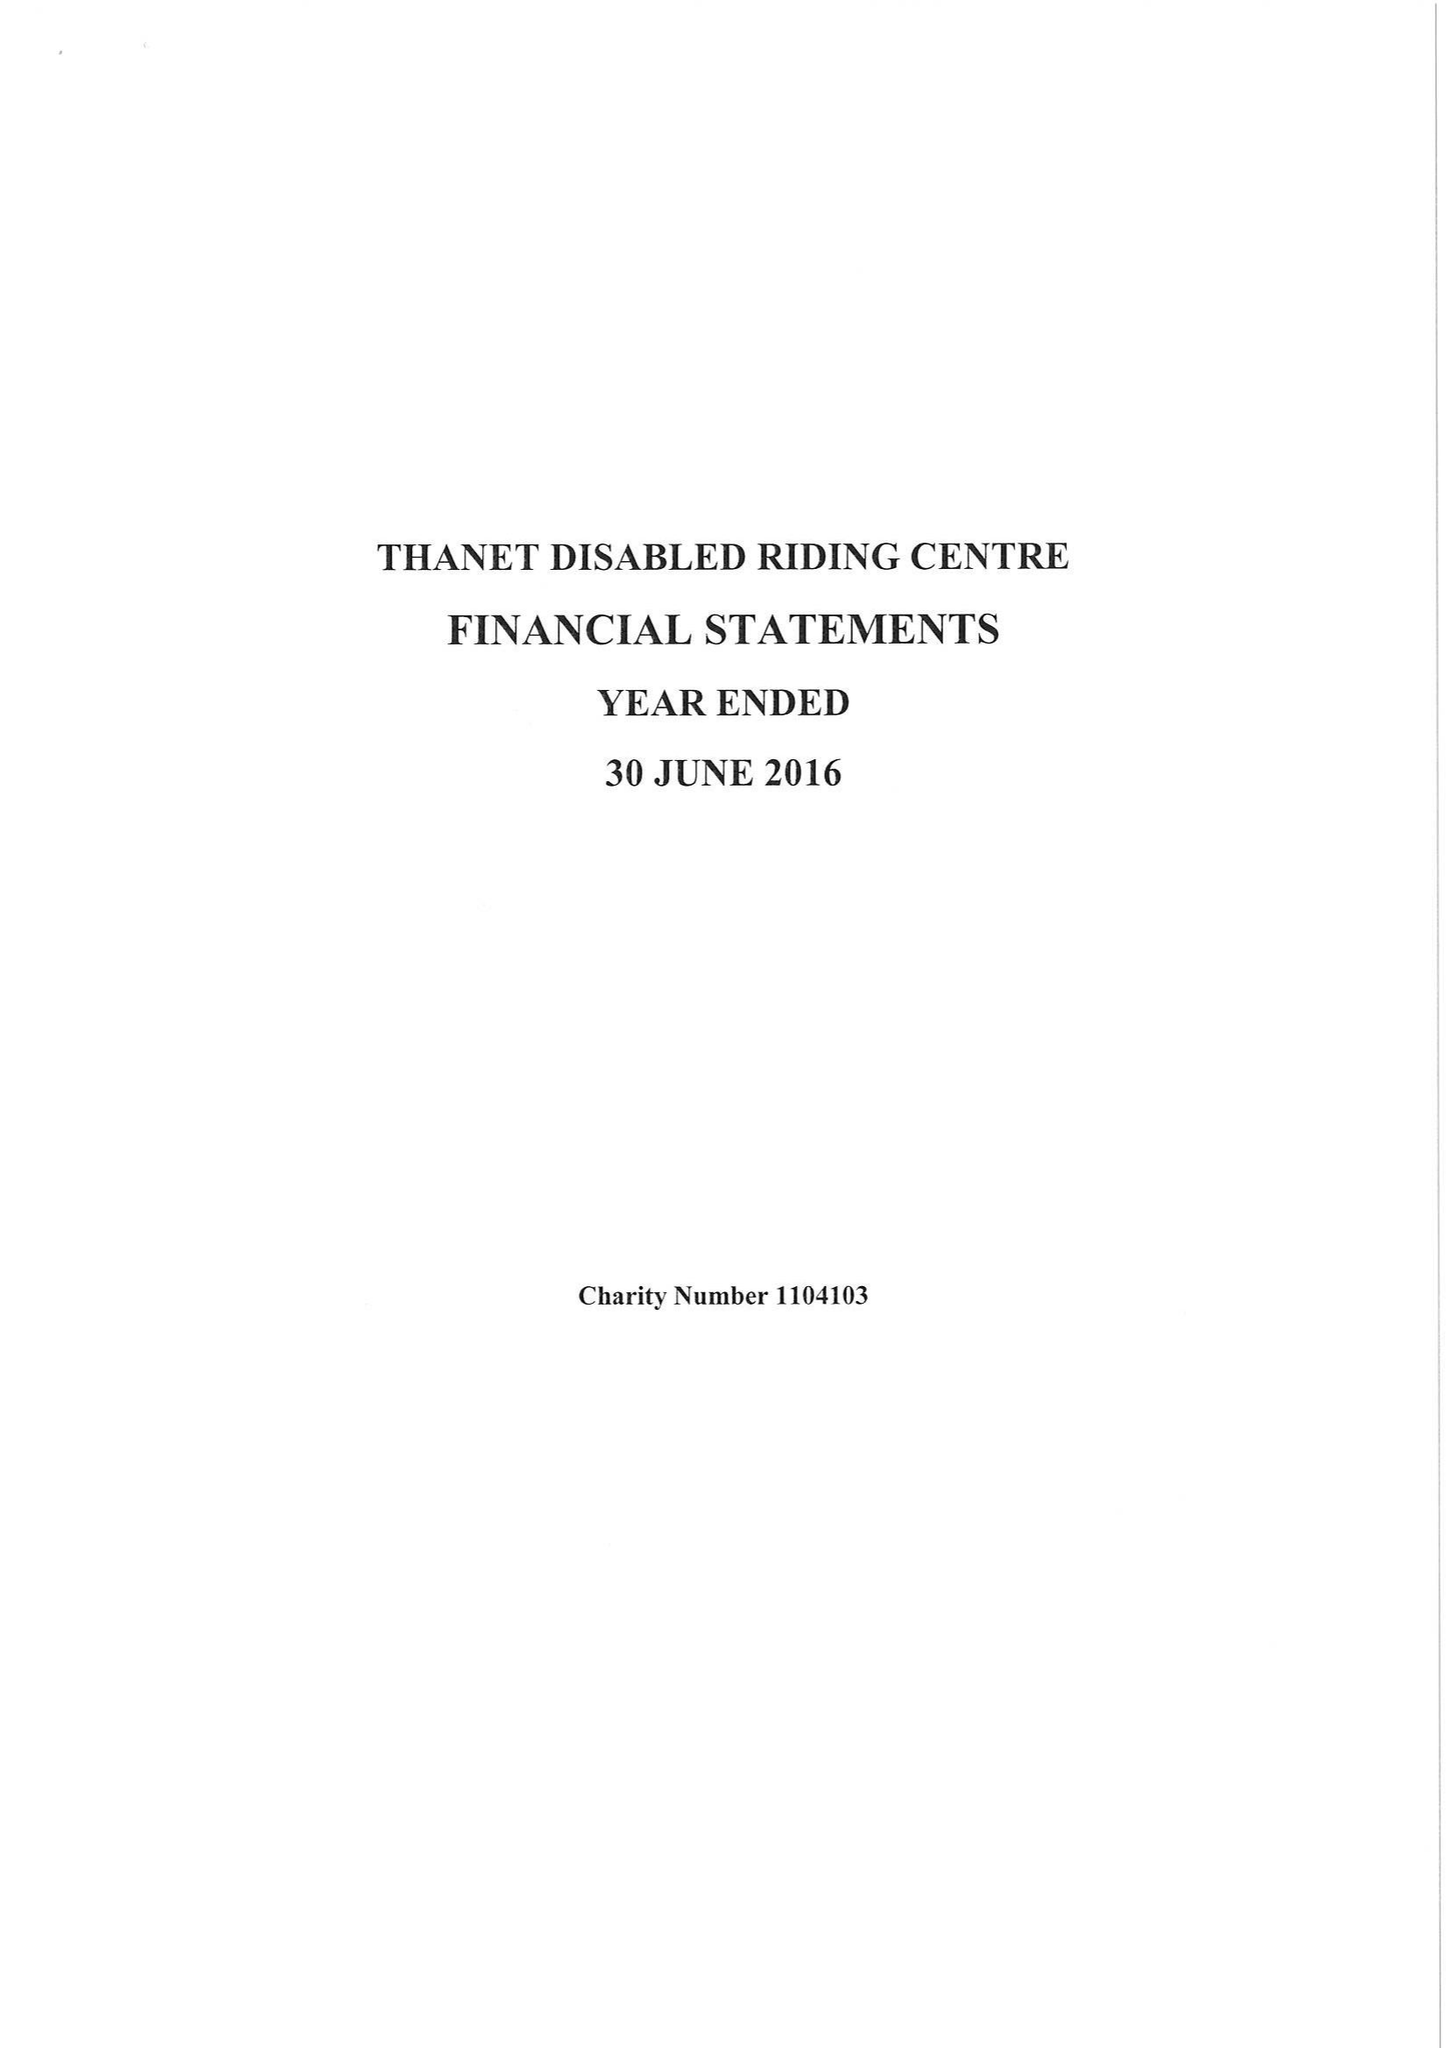What is the value for the spending_annually_in_british_pounds?
Answer the question using a single word or phrase. 41693.00 